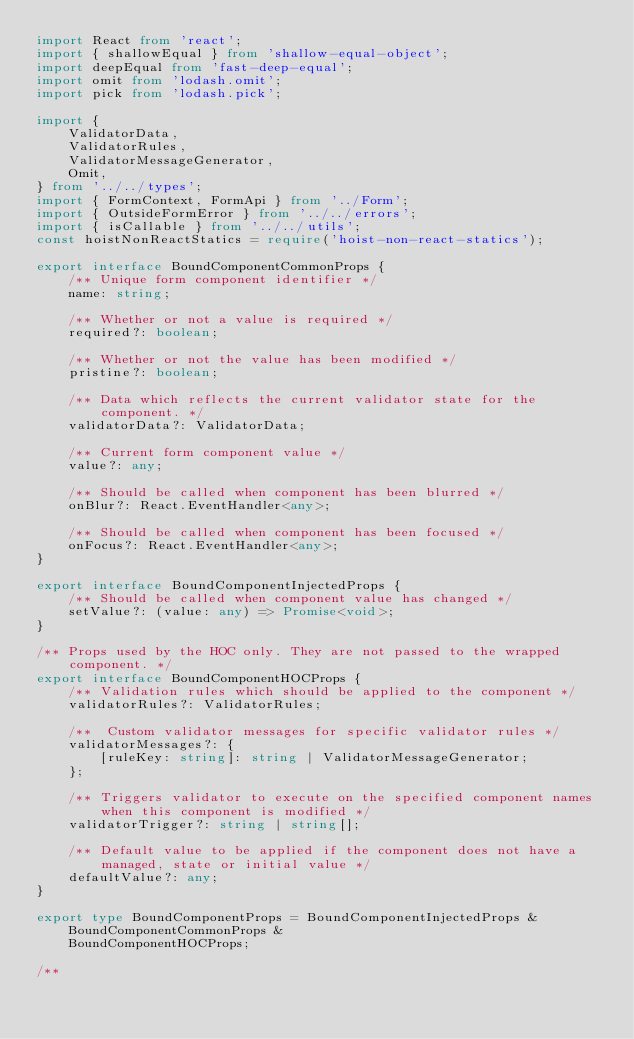<code> <loc_0><loc_0><loc_500><loc_500><_TypeScript_>import React from 'react';
import { shallowEqual } from 'shallow-equal-object';
import deepEqual from 'fast-deep-equal';
import omit from 'lodash.omit';
import pick from 'lodash.pick';

import {
    ValidatorData,
    ValidatorRules,
    ValidatorMessageGenerator,
    Omit,
} from '../../types';
import { FormContext, FormApi } from '../Form';
import { OutsideFormError } from '../../errors';
import { isCallable } from '../../utils';
const hoistNonReactStatics = require('hoist-non-react-statics');

export interface BoundComponentCommonProps {
    /** Unique form component identifier */
    name: string;

    /** Whether or not a value is required */
    required?: boolean;

    /** Whether or not the value has been modified */
    pristine?: boolean;

    /** Data which reflects the current validator state for the component. */
    validatorData?: ValidatorData;

    /** Current form component value */
    value?: any;

    /** Should be called when component has been blurred */
    onBlur?: React.EventHandler<any>;

    /** Should be called when component has been focused */
    onFocus?: React.EventHandler<any>;
}

export interface BoundComponentInjectedProps {
    /** Should be called when component value has changed */
    setValue?: (value: any) => Promise<void>;
}

/** Props used by the HOC only. They are not passed to the wrapped component. */
export interface BoundComponentHOCProps {
    /** Validation rules which should be applied to the component */
    validatorRules?: ValidatorRules;

    /**  Custom validator messages for specific validator rules */
    validatorMessages?: {
        [ruleKey: string]: string | ValidatorMessageGenerator;
    };

    /** Triggers validator to execute on the specified component names when this component is modified */
    validatorTrigger?: string | string[];

    /** Default value to be applied if the component does not have a managed, state or initial value */
    defaultValue?: any;
}

export type BoundComponentProps = BoundComponentInjectedProps &
    BoundComponentCommonProps &
    BoundComponentHOCProps;

/**</code> 